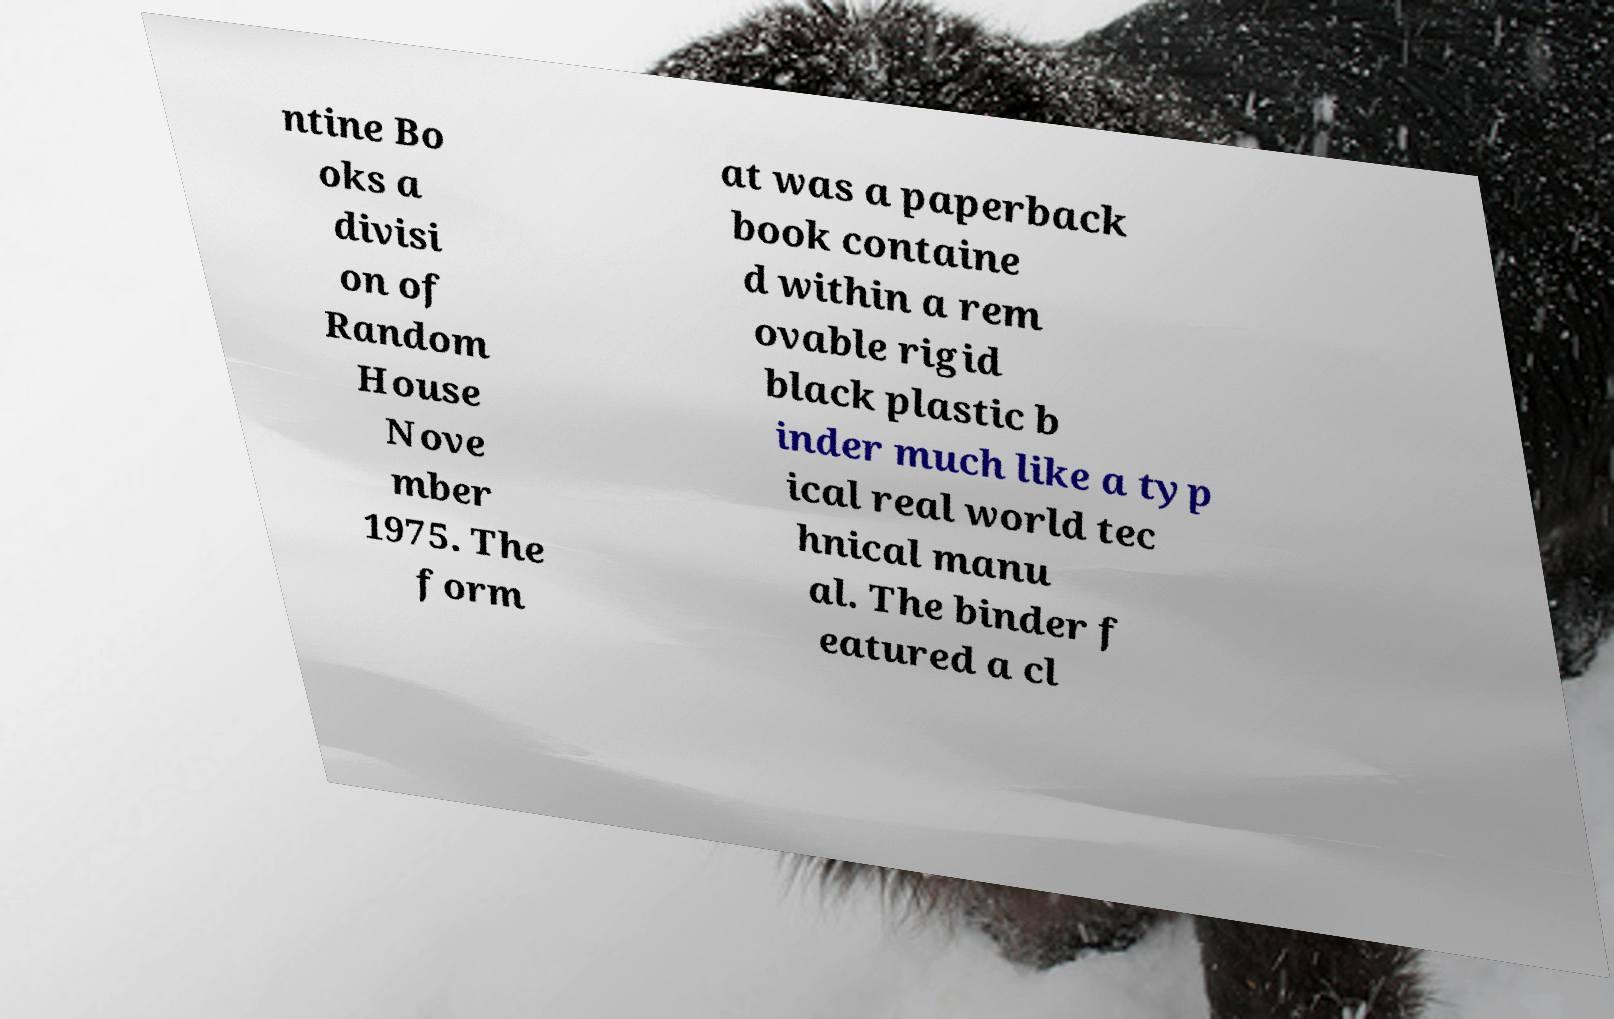Please read and relay the text visible in this image. What does it say? ntine Bo oks a divisi on of Random House Nove mber 1975. The form at was a paperback book containe d within a rem ovable rigid black plastic b inder much like a typ ical real world tec hnical manu al. The binder f eatured a cl 